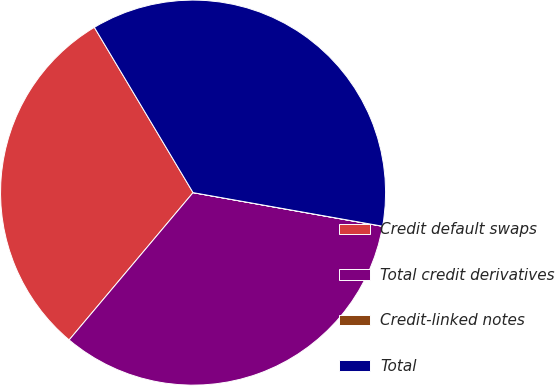Convert chart to OTSL. <chart><loc_0><loc_0><loc_500><loc_500><pie_chart><fcel>Credit default swaps<fcel>Total credit derivatives<fcel>Credit-linked notes<fcel>Total<nl><fcel>30.3%<fcel>33.33%<fcel>0.01%<fcel>36.36%<nl></chart> 